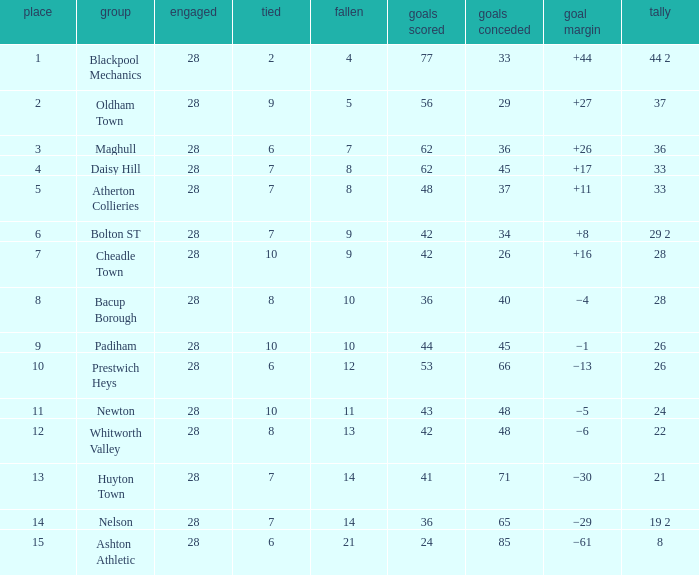What is the lowest drawn for entries with a lost of 13? 8.0. 